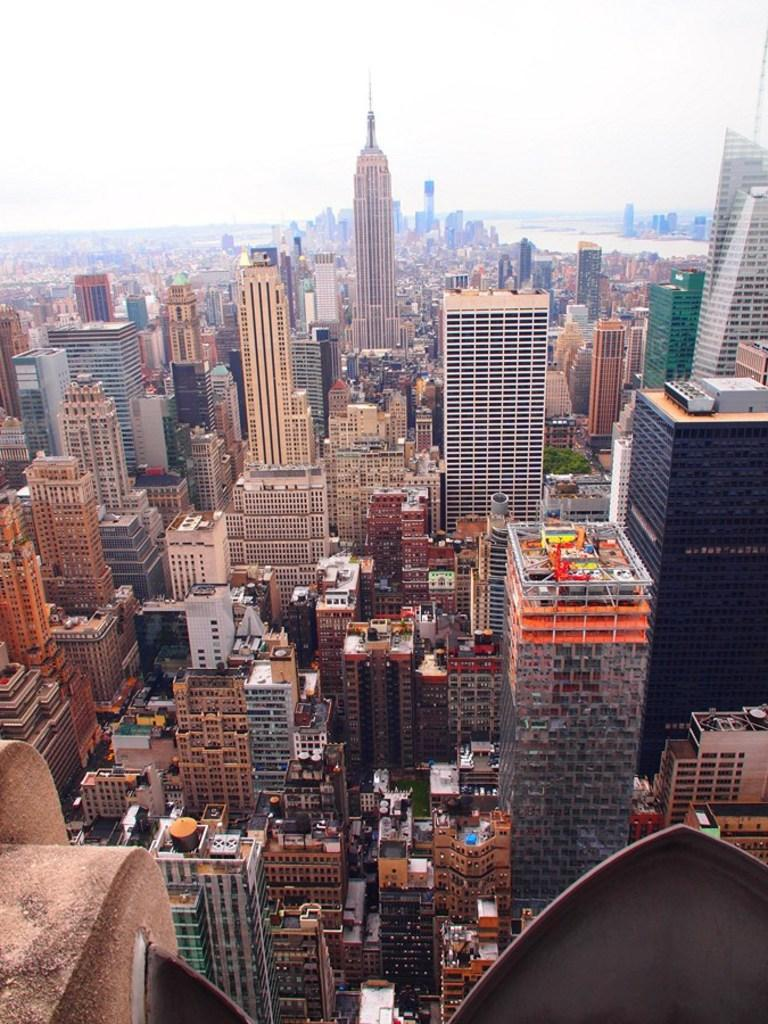What type of structures are present in the image? There is a group of buildings in the image. Are there any specific features of these buildings? Yes, there are towers in the image. What other natural elements can be seen in the image? There are trees and a water body visible in the image. How would you describe the sky in the image? The sky is visible in the image and appears cloudy. What is the value of the shape depicted in the image? There is no specific shape mentioned in the image, and therefore no value can be assigned to it. 